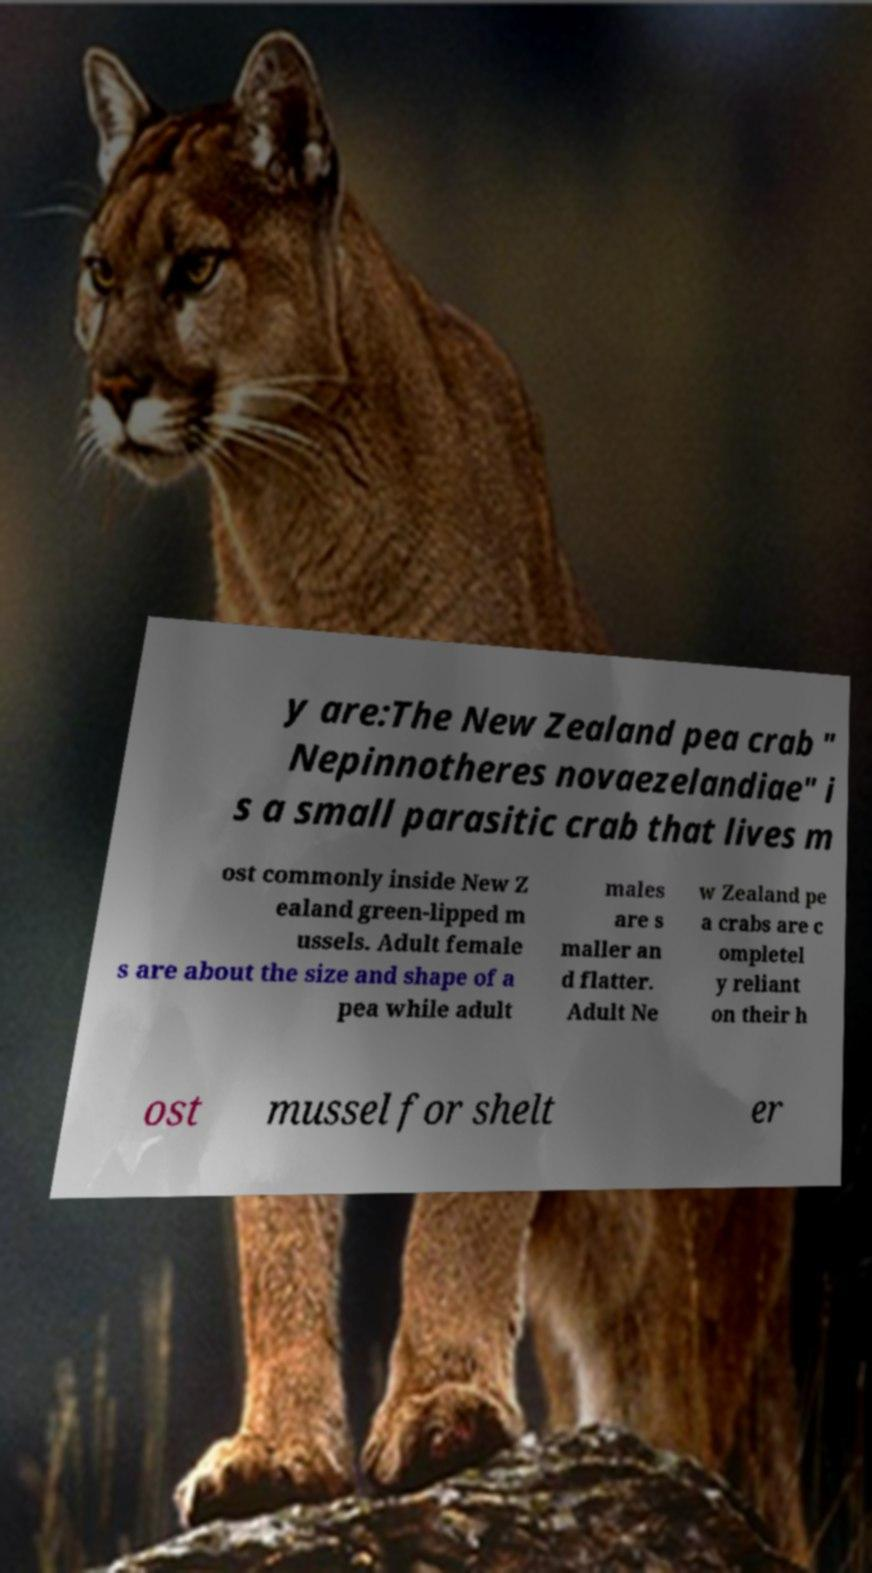For documentation purposes, I need the text within this image transcribed. Could you provide that? y are:The New Zealand pea crab " Nepinnotheres novaezelandiae" i s a small parasitic crab that lives m ost commonly inside New Z ealand green-lipped m ussels. Adult female s are about the size and shape of a pea while adult males are s maller an d flatter. Adult Ne w Zealand pe a crabs are c ompletel y reliant on their h ost mussel for shelt er 